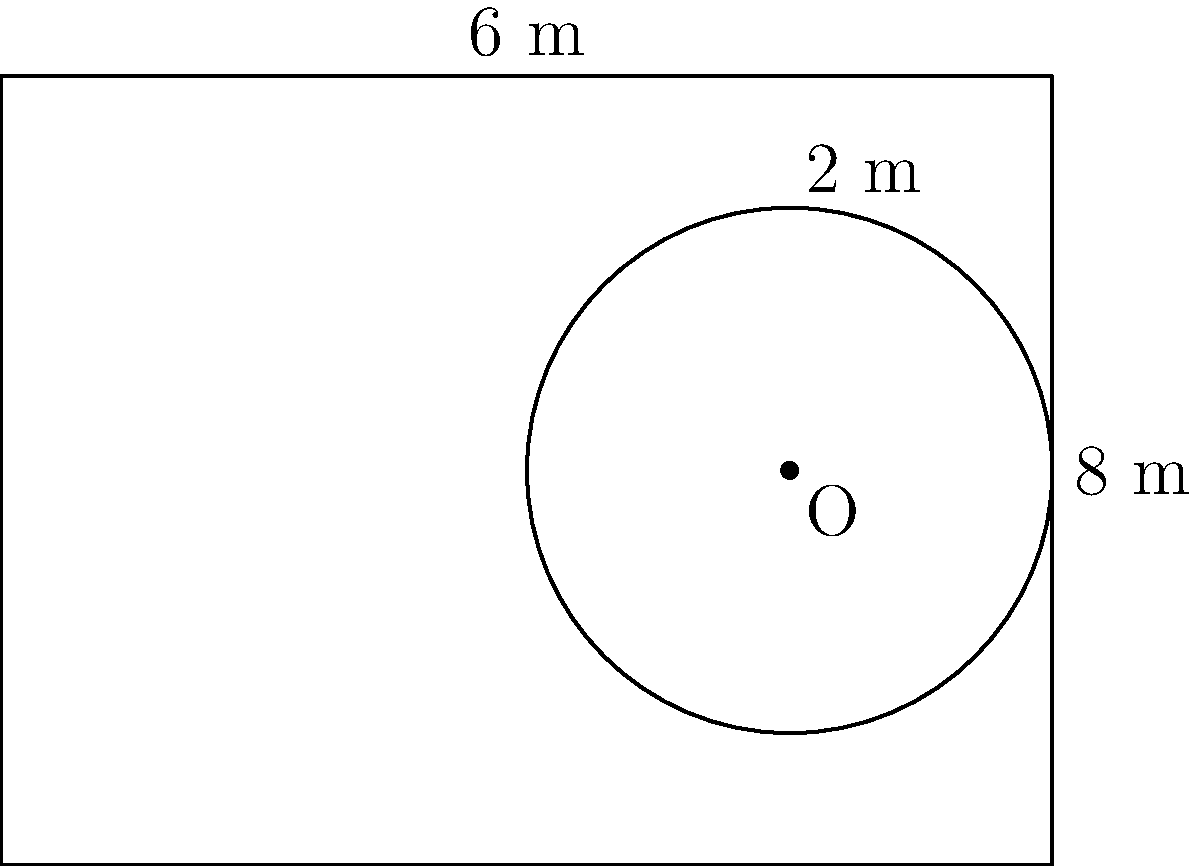You're designing a sensory room for your child with special needs. The room is rectangular with dimensions 8 m by 6 m, and you want to include a circular play area within it. The circular area has a radius of 2 m and its center is located 6 m from the left wall and 3 m from the bottom wall. Calculate the remaining floor area of the room that can be used for other activities. To find the remaining floor area, we need to:

1. Calculate the total area of the rectangular room:
   $A_{rectangle} = length \times width = 8 \text{ m} \times 6 \text{ m} = 48 \text{ m}^2$

2. Calculate the area of the circular play area:
   $A_{circle} = \pi r^2 = \pi \times (2 \text{ m})^2 = 4\pi \text{ m}^2$

3. Subtract the circular area from the total room area:
   $A_{remaining} = A_{rectangle} - A_{circle}$
   $A_{remaining} = 48 \text{ m}^2 - 4\pi \text{ m}^2$
   $A_{remaining} = 48 - 4\pi \text{ m}^2$
   $A_{remaining} \approx 35.44 \text{ m}^2$

Therefore, the remaining floor area for other activities is approximately 35.44 square meters.
Answer: $48 - 4\pi \approx 35.44 \text{ m}^2$ 